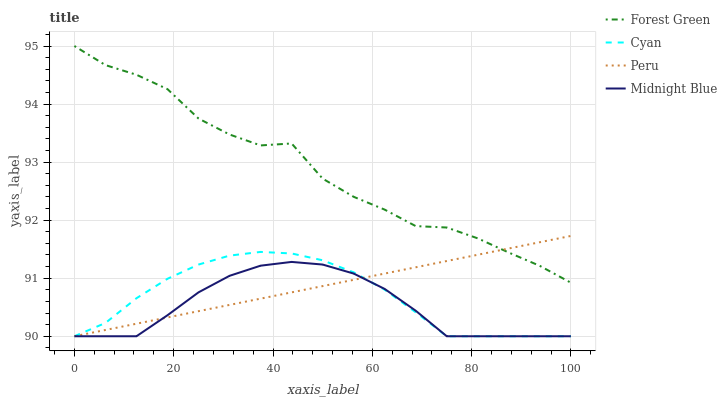Does Midnight Blue have the minimum area under the curve?
Answer yes or no. Yes. Does Forest Green have the maximum area under the curve?
Answer yes or no. Yes. Does Forest Green have the minimum area under the curve?
Answer yes or no. No. Does Midnight Blue have the maximum area under the curve?
Answer yes or no. No. Is Peru the smoothest?
Answer yes or no. Yes. Is Forest Green the roughest?
Answer yes or no. Yes. Is Midnight Blue the smoothest?
Answer yes or no. No. Is Midnight Blue the roughest?
Answer yes or no. No. Does Cyan have the lowest value?
Answer yes or no. Yes. Does Forest Green have the lowest value?
Answer yes or no. No. Does Forest Green have the highest value?
Answer yes or no. Yes. Does Midnight Blue have the highest value?
Answer yes or no. No. Is Cyan less than Forest Green?
Answer yes or no. Yes. Is Forest Green greater than Cyan?
Answer yes or no. Yes. Does Peru intersect Cyan?
Answer yes or no. Yes. Is Peru less than Cyan?
Answer yes or no. No. Is Peru greater than Cyan?
Answer yes or no. No. Does Cyan intersect Forest Green?
Answer yes or no. No. 